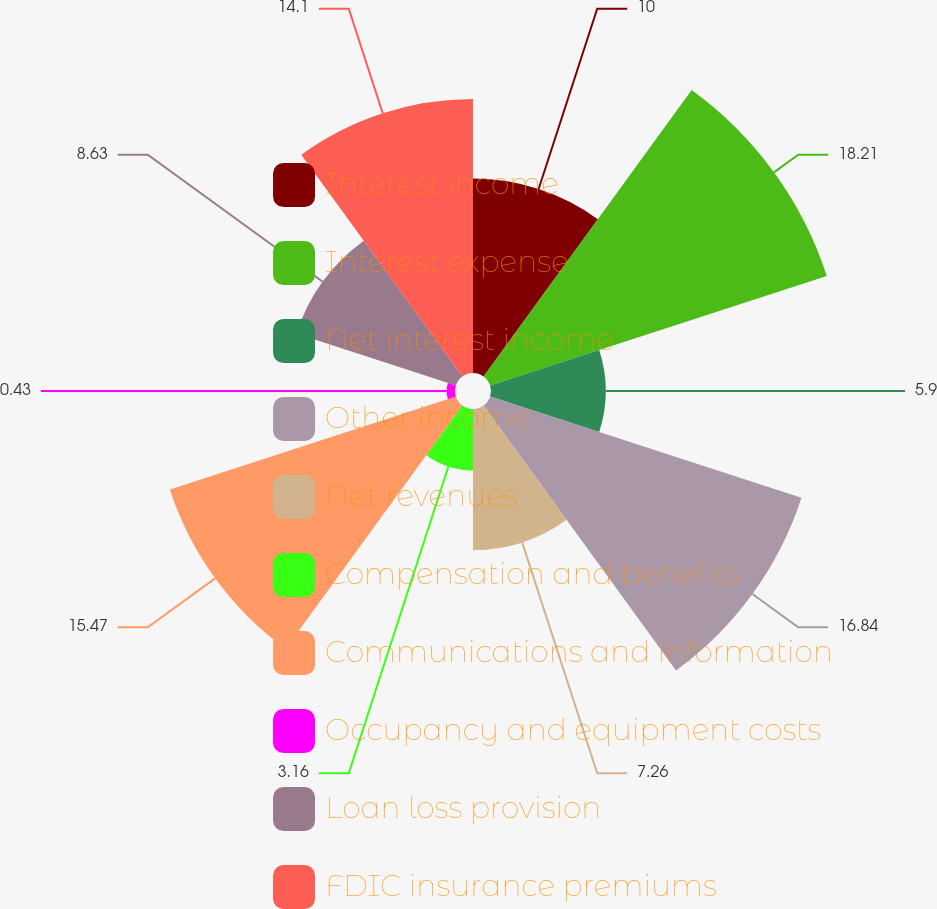Convert chart to OTSL. <chart><loc_0><loc_0><loc_500><loc_500><pie_chart><fcel>Interest income<fcel>Interest expense<fcel>Net interest income<fcel>Other income<fcel>Net revenues<fcel>Compensation and benefits<fcel>Communications and information<fcel>Occupancy and equipment costs<fcel>Loan loss provision<fcel>FDIC insurance premiums<nl><fcel>10.0%<fcel>18.21%<fcel>5.9%<fcel>16.84%<fcel>7.26%<fcel>3.16%<fcel>15.47%<fcel>0.43%<fcel>8.63%<fcel>14.1%<nl></chart> 